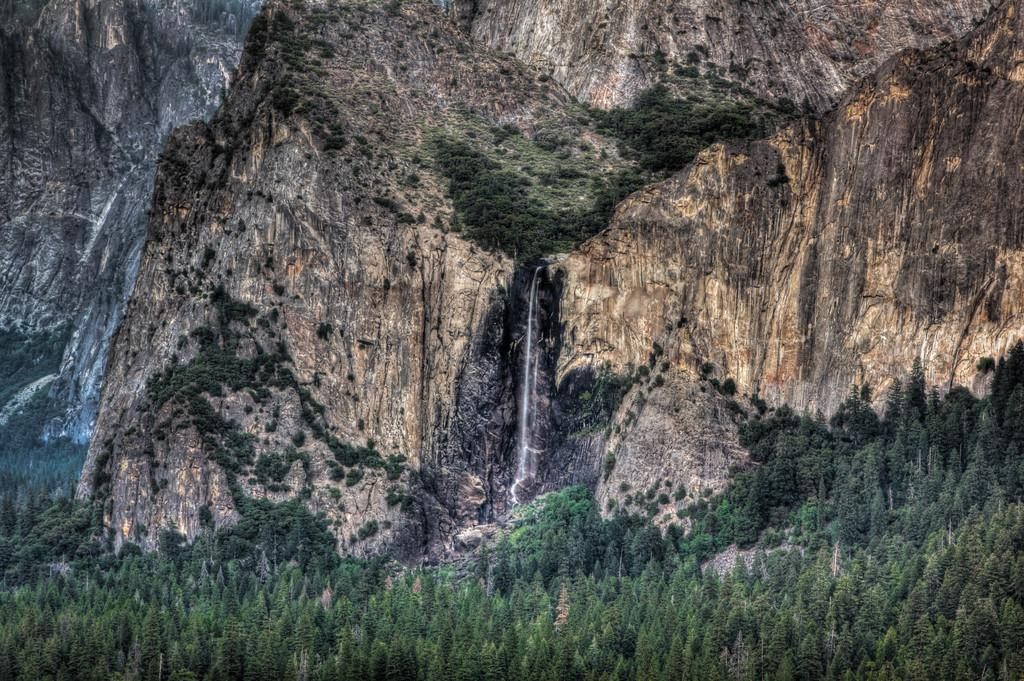What type of natural landscape is depicted in the image? The image contains mountains. What specific feature can be seen in the middle of the image? There is a waterfall in the middle of the image. What type of vegetation is present at the bottom of the image? There are plants at the bottom of the image. What type of ornament is hanging from the waterfall in the image? There is no ornament hanging from the waterfall in the image; it is a natural waterfall. Can you see a cat playing near the waterfall in the image? There is no cat present in the image; it features a waterfall in a natural landscape. 